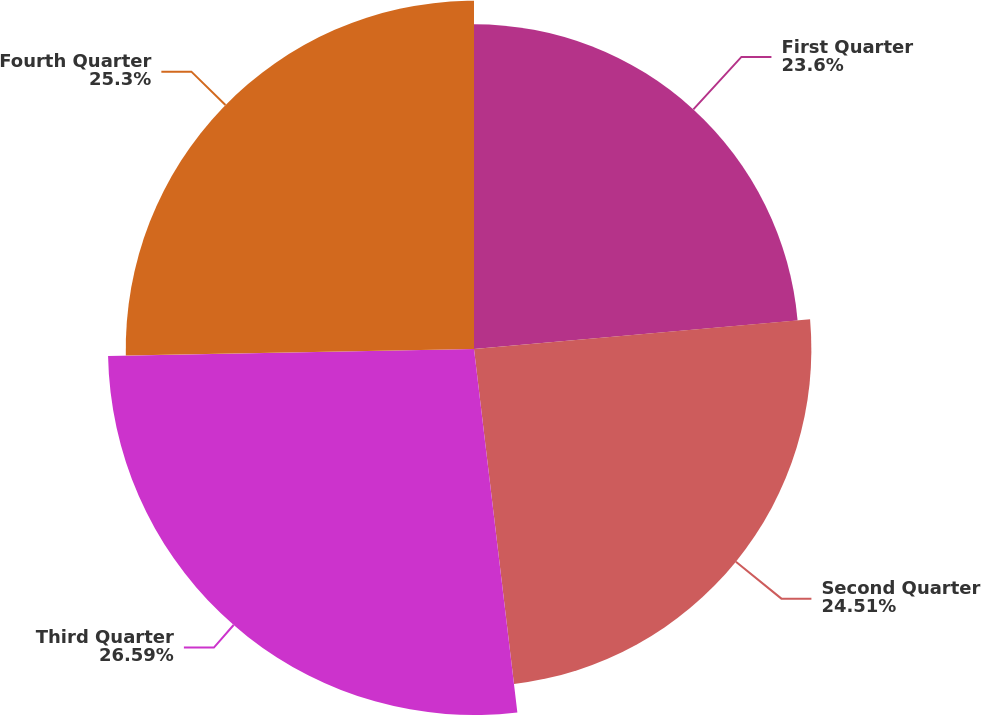<chart> <loc_0><loc_0><loc_500><loc_500><pie_chart><fcel>First Quarter<fcel>Second Quarter<fcel>Third Quarter<fcel>Fourth Quarter<nl><fcel>23.6%<fcel>24.51%<fcel>26.59%<fcel>25.3%<nl></chart> 